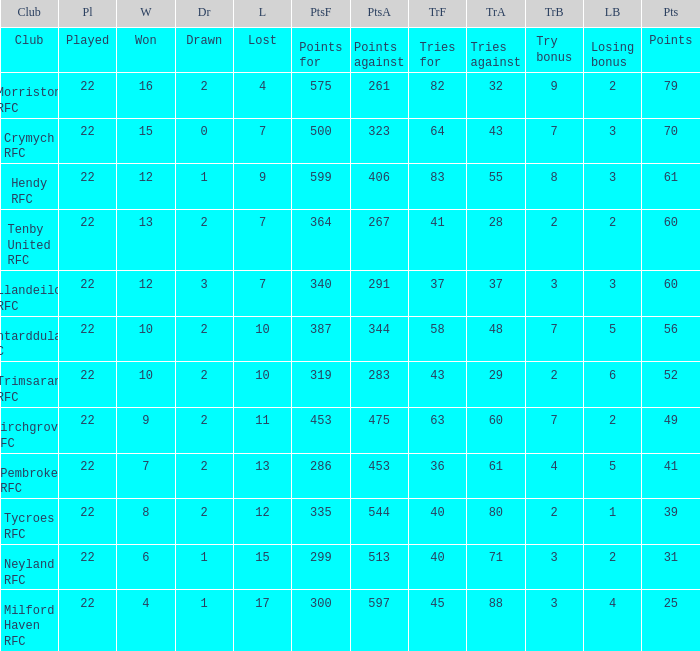 how many losing bonus with won being 10 and points against being 283 1.0. Help me parse the entirety of this table. {'header': ['Club', 'Pl', 'W', 'Dr', 'L', 'PtsF', 'PtsA', 'TrF', 'TrA', 'TrB', 'LB', 'Pts'], 'rows': [['Club', 'Played', 'Won', 'Drawn', 'Lost', 'Points for', 'Points against', 'Tries for', 'Tries against', 'Try bonus', 'Losing bonus', 'Points'], ['Morriston RFC', '22', '16', '2', '4', '575', '261', '82', '32', '9', '2', '79'], ['Crymych RFC', '22', '15', '0', '7', '500', '323', '64', '43', '7', '3', '70'], ['Hendy RFC', '22', '12', '1', '9', '599', '406', '83', '55', '8', '3', '61'], ['Tenby United RFC', '22', '13', '2', '7', '364', '267', '41', '28', '2', '2', '60'], ['Llandeilo RFC', '22', '12', '3', '7', '340', '291', '37', '37', '3', '3', '60'], ['Pontarddulais RFC', '22', '10', '2', '10', '387', '344', '58', '48', '7', '5', '56'], ['Trimsaran RFC', '22', '10', '2', '10', '319', '283', '43', '29', '2', '6', '52'], ['Birchgrove RFC', '22', '9', '2', '11', '453', '475', '63', '60', '7', '2', '49'], ['Pembroke RFC', '22', '7', '2', '13', '286', '453', '36', '61', '4', '5', '41'], ['Tycroes RFC', '22', '8', '2', '12', '335', '544', '40', '80', '2', '1', '39'], ['Neyland RFC', '22', '6', '1', '15', '299', '513', '40', '71', '3', '2', '31'], ['Milford Haven RFC', '22', '4', '1', '17', '300', '597', '45', '88', '3', '4', '25']]} 